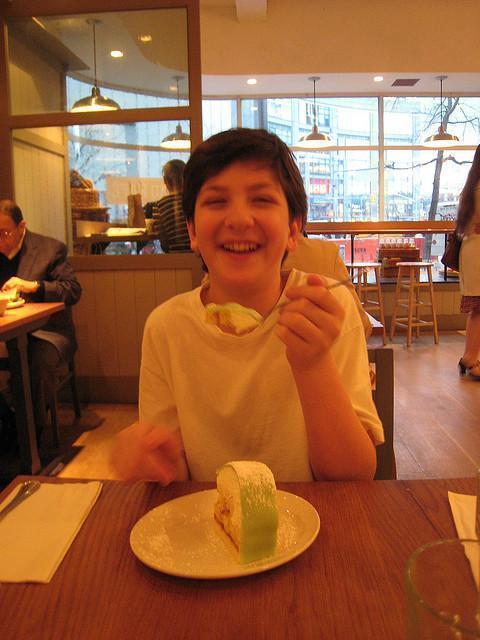What is this cake called?
Pick the correct solution from the four options below to address the question.
Options: Princess cake, rose cake, green cake, plum cake. Princess cake. 